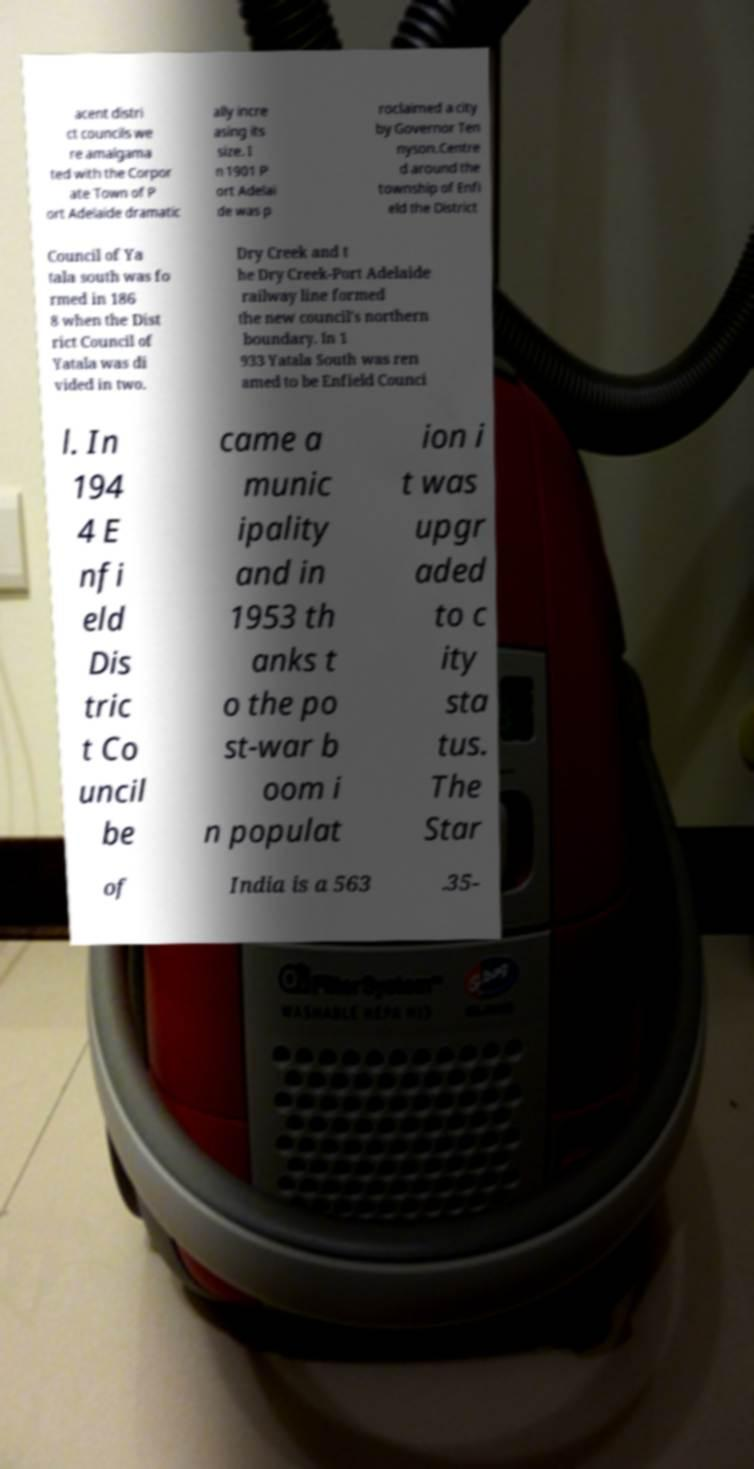There's text embedded in this image that I need extracted. Can you transcribe it verbatim? acent distri ct councils we re amalgama ted with the Corpor ate Town of P ort Adelaide dramatic ally incre asing its size. I n 1901 P ort Adelai de was p roclaimed a city by Governor Ten nyson.Centre d around the township of Enfi eld the District Council of Ya tala south was fo rmed in 186 8 when the Dist rict Council of Yatala was di vided in two. Dry Creek and t he Dry Creek-Port Adelaide railway line formed the new council's northern boundary. In 1 933 Yatala South was ren amed to be Enfield Counci l. In 194 4 E nfi eld Dis tric t Co uncil be came a munic ipality and in 1953 th anks t o the po st-war b oom i n populat ion i t was upgr aded to c ity sta tus. The Star of India is a 563 .35- 